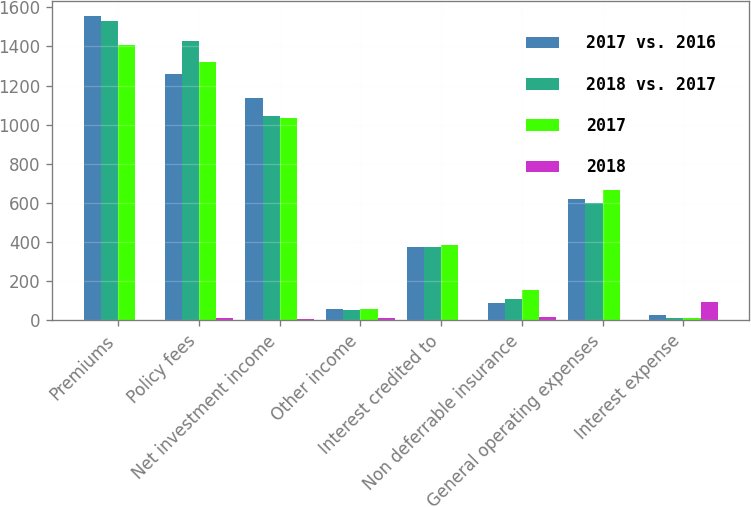Convert chart to OTSL. <chart><loc_0><loc_0><loc_500><loc_500><stacked_bar_chart><ecel><fcel>Premiums<fcel>Policy fees<fcel>Net investment income<fcel>Other income<fcel>Interest credited to<fcel>Non deferrable insurance<fcel>General operating expenses<fcel>Interest expense<nl><fcel>2017 vs. 2016<fcel>1554<fcel>1258<fcel>1137<fcel>58<fcel>374<fcel>89<fcel>620<fcel>25<nl><fcel>2018 vs. 2017<fcel>1530<fcel>1430<fcel>1044<fcel>52<fcel>376<fcel>109<fcel>601<fcel>13<nl><fcel>2017<fcel>1407<fcel>1319<fcel>1035<fcel>57<fcel>386<fcel>155<fcel>668<fcel>12<nl><fcel>2018<fcel>2<fcel>12<fcel>9<fcel>12<fcel>1<fcel>18<fcel>3<fcel>92<nl></chart> 